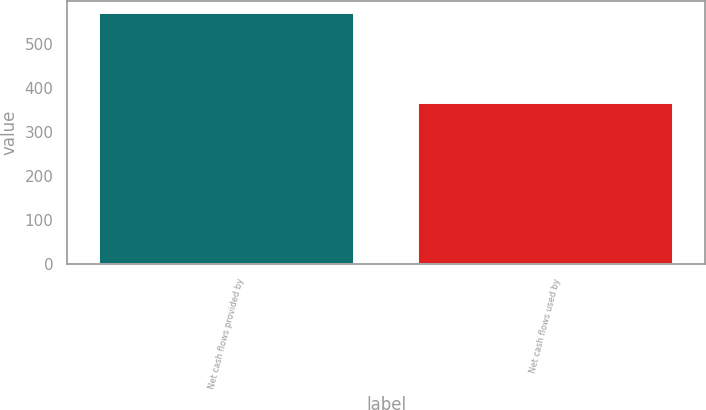Convert chart. <chart><loc_0><loc_0><loc_500><loc_500><bar_chart><fcel>Net cash flows provided by<fcel>Net cash flows used by<nl><fcel>571<fcel>367.7<nl></chart> 